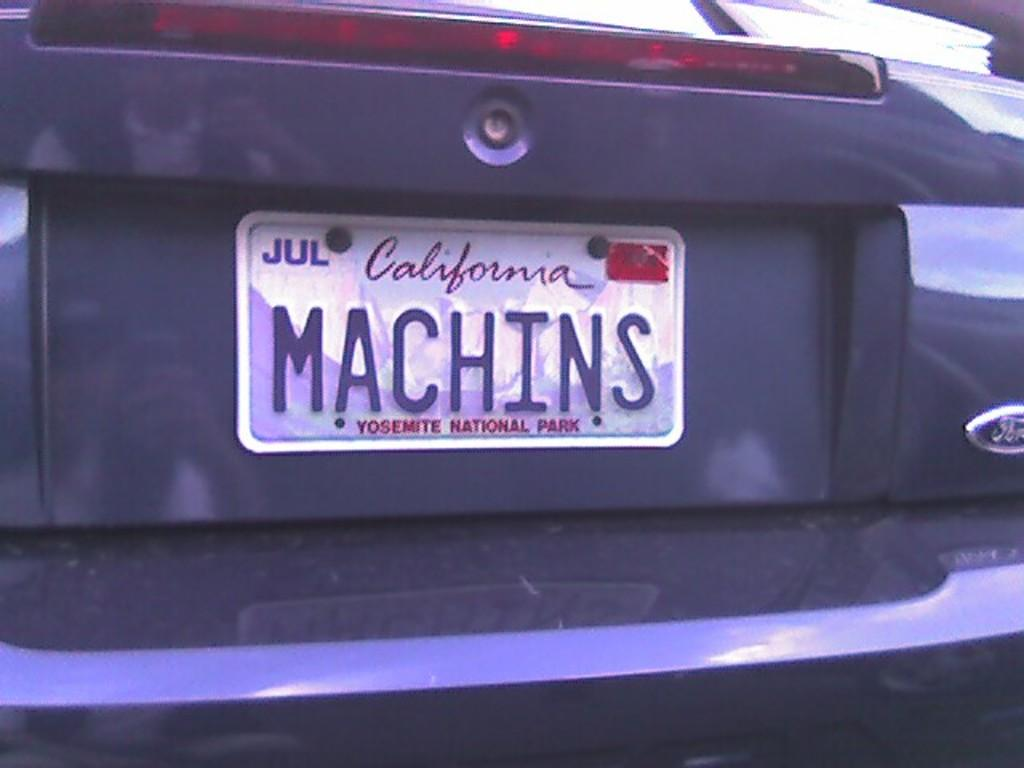<image>
Summarize the visual content of the image. A ford with a Yosemite National Park license plate. 